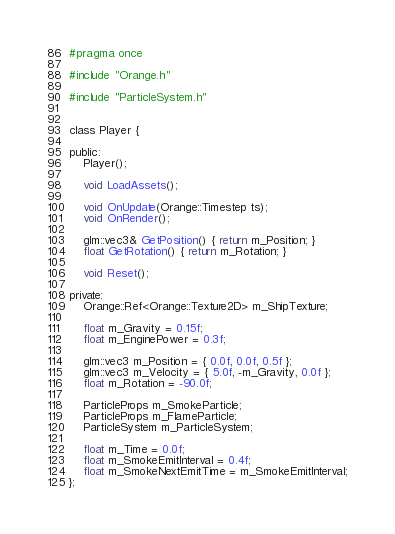Convert code to text. <code><loc_0><loc_0><loc_500><loc_500><_C_>#pragma once

#include "Orange.h"

#include "ParticleSystem.h"


class Player {

public:
	Player();

	void LoadAssets();

	void OnUpdate(Orange::Timestep ts);
	void OnRender();

	glm::vec3& GetPosition() { return m_Position; }
	float GetRotation() { return m_Rotation; }

	void Reset();

private:
	Orange::Ref<Orange::Texture2D> m_ShipTexture;

	float m_Gravity = 0.15f;
	float m_EnginePower = 0.3f;

	glm::vec3 m_Position = { 0.0f, 0.0f, 0.5f };
	glm::vec3 m_Velocity = { 5.0f, -m_Gravity, 0.0f };
	float m_Rotation = -90.0f;

	ParticleProps m_SmokeParticle;
	ParticleProps m_FlameParticle;
	ParticleSystem m_ParticleSystem;

	float m_Time = 0.0f;
	float m_SmokeEmitInterval = 0.4f;
	float m_SmokeNextEmitTime = m_SmokeEmitInterval;
};</code> 